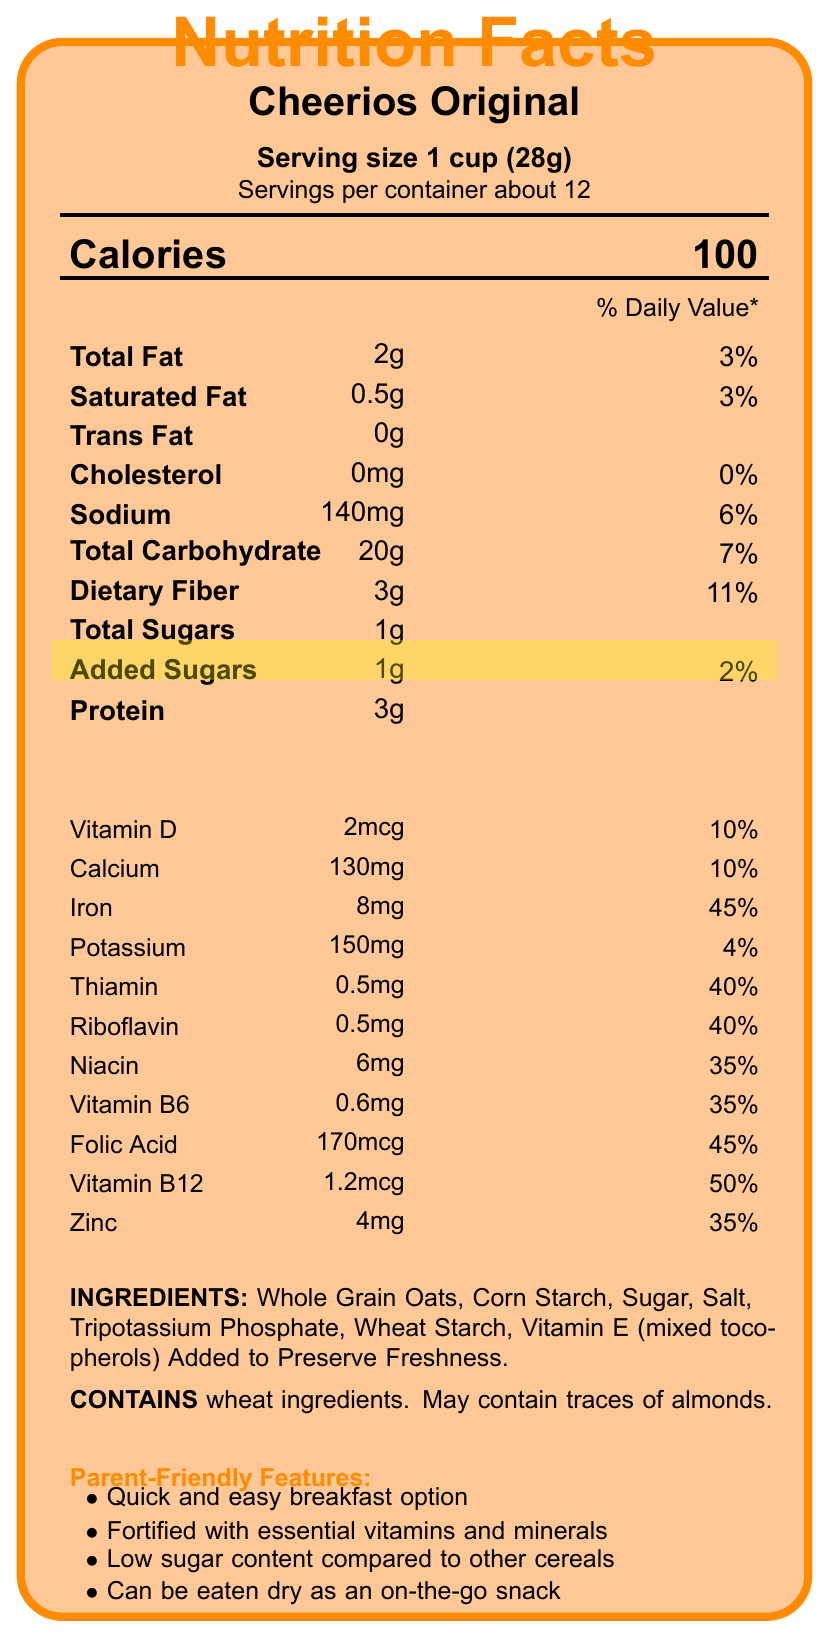what is the serving size of Cheerios Original? The serving size is mentioned near the top of the document under the title "Serving size 1 cup (28g)".
Answer: 1 cup (28g) how many servings per container are there? The document specifies servings per container as "About 12" just below the serving size.
Answer: About 12 how many grams of total fat are in one serving? The nutrient information section lists Total Fat as "2g".
Answer: 2g what percentage of the daily value for iron does one serving provide? The document indicates that one serving provides 45% of the daily value for iron in the vitamins and minerals section.
Answer: 45% how many grams of protein are in each serving? The protein content per serving is listed as "3g" in the nutrient information section.
Answer: 3g Which of the following parent-friendly features is NOT listed in the document? A. Contains probiotics B. Quick and easy breakfast option C. Fortified with essential vitamins and minerals D. Low sugar content compared to other cereals The document does not mention "Contains probiotics"; it lists the other options as features.
Answer: A how much sodium is in a serving? The amount of sodium per serving is listed as "140mg" in the nutrient information section.
Answer: 140mg how many grams of added sugars does Cheerios Original contain per serving? The document lists "Added Sugars" as "1g" under the highlighted sugar content.
Answer: 1g what are the first three ingredients listed for Cheerios Original? The ingredients section lists the first three ingredients as Whole Grain Oats, Corn Starch, and Sugar.
Answer: Whole Grain Oats, Corn Starch, Sugar Is this cereal considered low in sugar? The document highlights "Low sugar content compared to many other children's cereals" under parent-friendly features, indicating that it is considered low in sugar.
Answer: Yes Does Cheerios Original contain any cholesterol? The nutrient information section lists Cholesterol as "0mg", meaning it contains no cholesterol.
Answer: No summarize the main nutritional benefits outlined in the document. The document emphasizes Cheerios Original's nutritional benefits, such as being low in sugar and fat, high in essential vitamins and minerals, and made with whole grains. The cereal is also promoted for its convenience for busy families.
Answer: Cheerios Original is a fortified cereal that provides essential vitamins and minerals, is low in sugar, and is made with whole grain as the first ingredient. It is a good source of fiber and has a low calorie and fat content. The cereal also highlights its convenience as a quick breakfast option and its suitability as a dry snack for on-the-go families. what vitamin has the highest daily value percentage in Cheerios Original? A. Vitamin D B. Vitamin B6 C. Vitamin B12 D. Iron The document lists Vitamin B12 with a daily value percentage of 50%, which is the highest among the vitamins.
Answer: C Does the document specify if Cheerios Original contains almonds? The allergen information section states, "May contain traces of almonds."
Answer: May contain traces of almonds how many calories are in one serving of Cheerios Original? The document clearly states that there are 100 calories per serving near the top of the page.
Answer: 100 who manufactures Cheerios Original cereal? The document does not provide any information about the manufacturer of Cheerios Original cereal.
Answer: Not enough information 